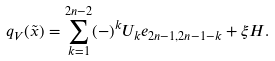<formula> <loc_0><loc_0><loc_500><loc_500>q _ { V } ( \tilde { x } ) = \sum _ { k = 1 } ^ { 2 n - 2 } ( - ) ^ { k } U _ { k } e _ { 2 n - 1 , 2 n - 1 - k } + \xi H .</formula> 